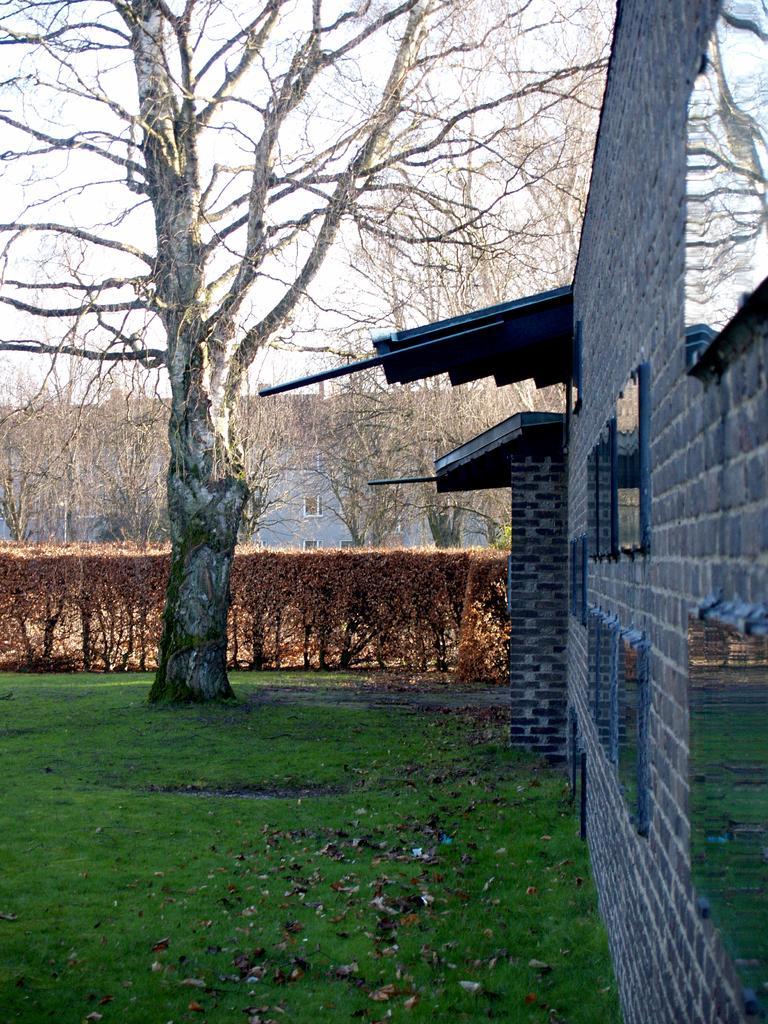In one or two sentences, can you explain what this image depicts? In this image we can see houses, there are trees, plants, there are reflections of trees and grass in the windows, there are leaves on the ground, also we can see the sky. 